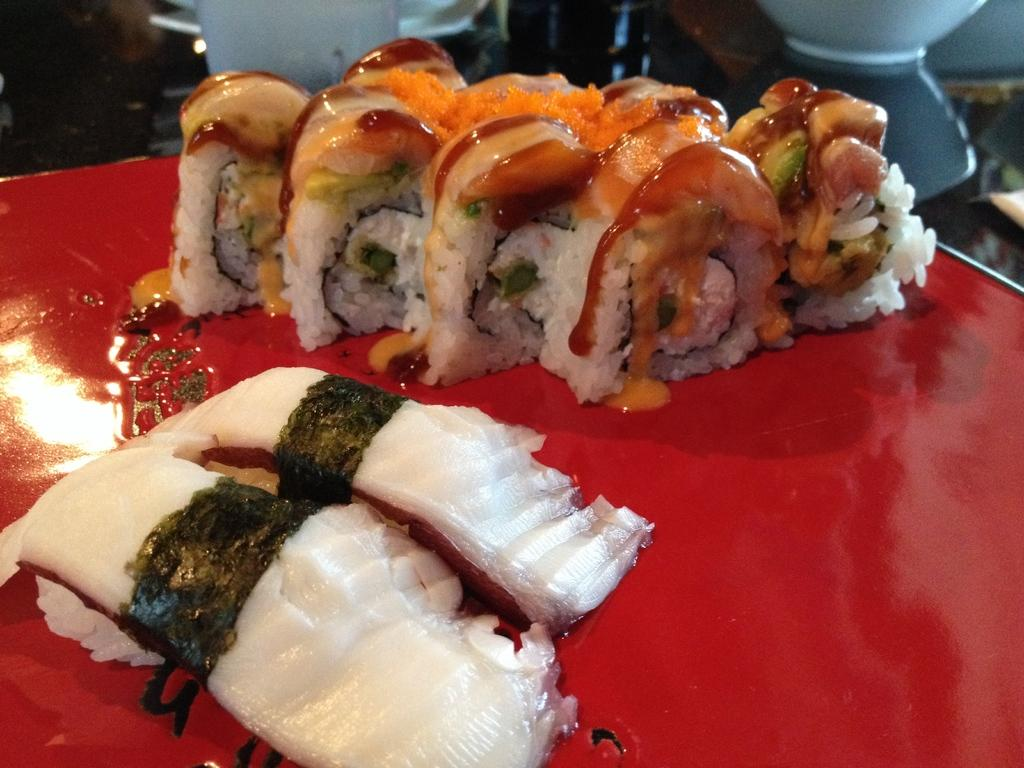What is the color of the object in the image? The object in the image is red. What is the red object being used for? The red object is being used to hold food. Can you describe the color of the food on the red object? The color of the food is brown and white. How many flowers are growing on the red object in the image? There are no flowers present on the red object in the image. 